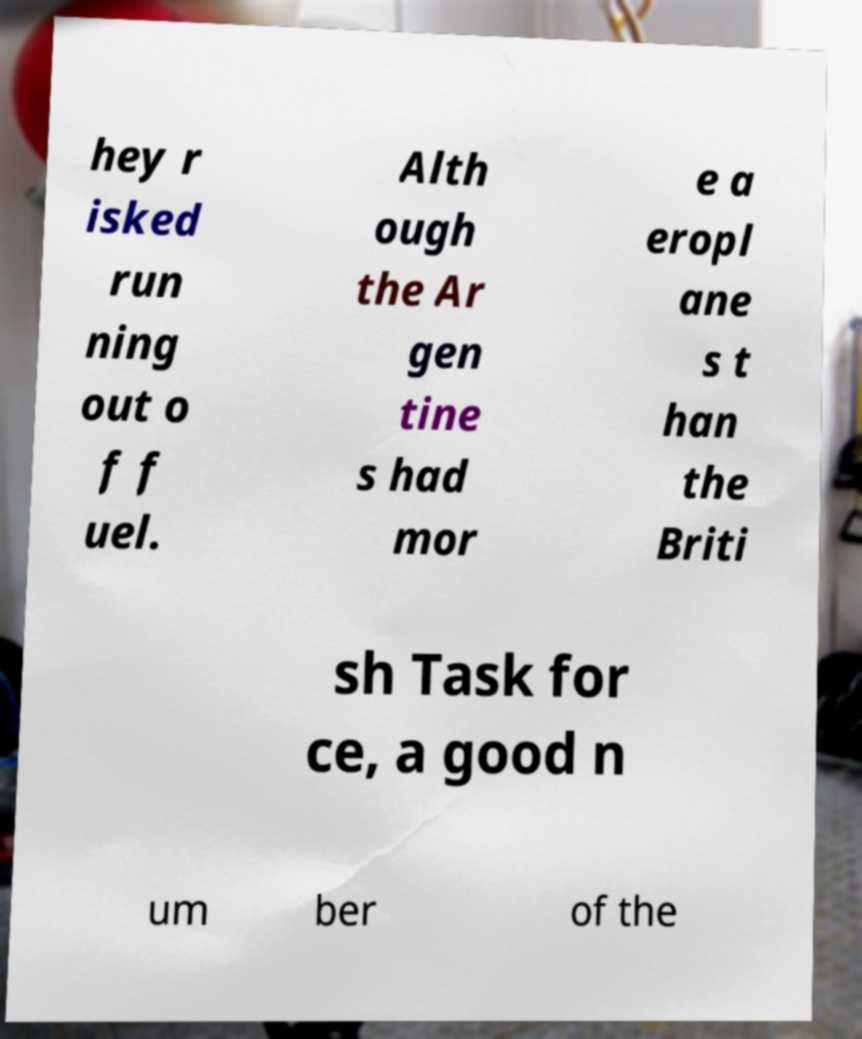What messages or text are displayed in this image? I need them in a readable, typed format. hey r isked run ning out o f f uel. Alth ough the Ar gen tine s had mor e a eropl ane s t han the Briti sh Task for ce, a good n um ber of the 